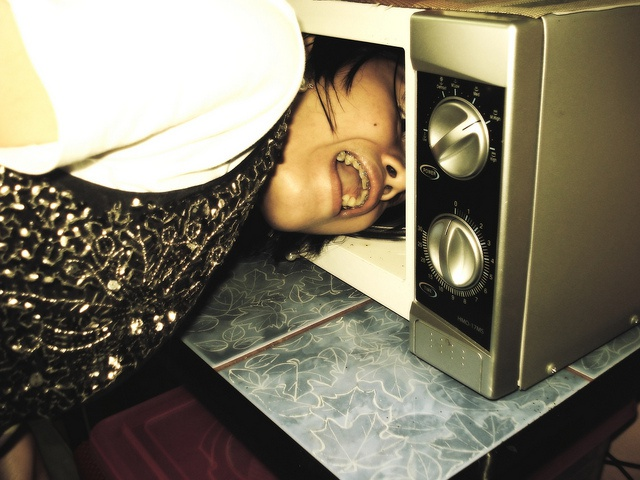Describe the objects in this image and their specific colors. I can see people in khaki, white, black, and tan tones and microwave in khaki, gray, black, lightyellow, and olive tones in this image. 